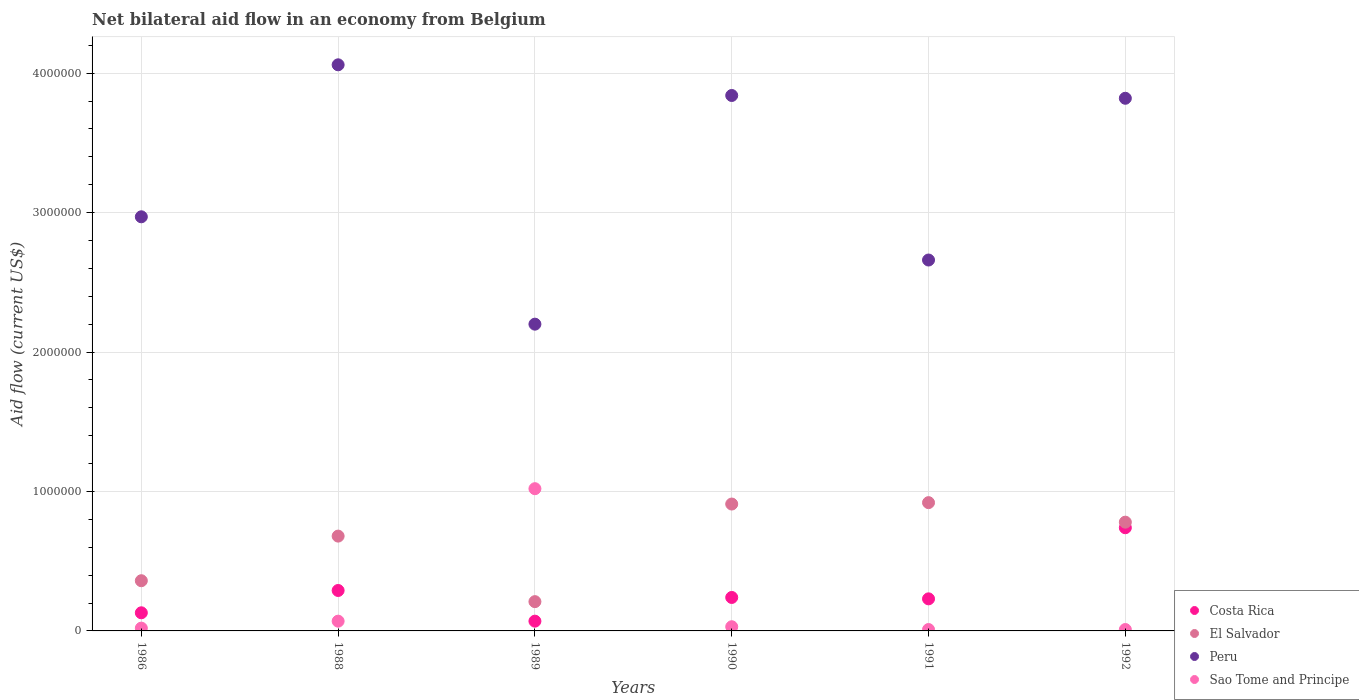Is the number of dotlines equal to the number of legend labels?
Ensure brevity in your answer.  Yes. What is the net bilateral aid flow in Costa Rica in 1986?
Your answer should be compact. 1.30e+05. Across all years, what is the maximum net bilateral aid flow in Costa Rica?
Make the answer very short. 7.40e+05. What is the total net bilateral aid flow in Peru in the graph?
Offer a very short reply. 1.96e+07. What is the difference between the net bilateral aid flow in Costa Rica in 1989 and that in 1992?
Make the answer very short. -6.70e+05. What is the difference between the net bilateral aid flow in Peru in 1989 and the net bilateral aid flow in El Salvador in 1990?
Make the answer very short. 1.29e+06. What is the average net bilateral aid flow in Peru per year?
Offer a terse response. 3.26e+06. In the year 1988, what is the difference between the net bilateral aid flow in Sao Tome and Principe and net bilateral aid flow in Costa Rica?
Ensure brevity in your answer.  -2.20e+05. What is the ratio of the net bilateral aid flow in Costa Rica in 1989 to that in 1990?
Your response must be concise. 0.29. Is the net bilateral aid flow in El Salvador in 1988 less than that in 1991?
Provide a short and direct response. Yes. Is the difference between the net bilateral aid flow in Sao Tome and Principe in 1988 and 1990 greater than the difference between the net bilateral aid flow in Costa Rica in 1988 and 1990?
Your answer should be very brief. No. What is the difference between the highest and the lowest net bilateral aid flow in Sao Tome and Principe?
Provide a short and direct response. 1.01e+06. In how many years, is the net bilateral aid flow in Costa Rica greater than the average net bilateral aid flow in Costa Rica taken over all years?
Your response must be concise. 2. Is the sum of the net bilateral aid flow in Costa Rica in 1990 and 1991 greater than the maximum net bilateral aid flow in El Salvador across all years?
Your answer should be compact. No. Is it the case that in every year, the sum of the net bilateral aid flow in Peru and net bilateral aid flow in Sao Tome and Principe  is greater than the sum of net bilateral aid flow in Costa Rica and net bilateral aid flow in El Salvador?
Offer a very short reply. Yes. Is it the case that in every year, the sum of the net bilateral aid flow in El Salvador and net bilateral aid flow in Peru  is greater than the net bilateral aid flow in Costa Rica?
Offer a terse response. Yes. Does the net bilateral aid flow in Costa Rica monotonically increase over the years?
Offer a terse response. No. Is the net bilateral aid flow in El Salvador strictly less than the net bilateral aid flow in Costa Rica over the years?
Your answer should be compact. No. How many dotlines are there?
Your answer should be very brief. 4. What is the difference between two consecutive major ticks on the Y-axis?
Provide a short and direct response. 1.00e+06. Does the graph contain grids?
Your answer should be very brief. Yes. How many legend labels are there?
Your answer should be compact. 4. How are the legend labels stacked?
Your answer should be very brief. Vertical. What is the title of the graph?
Provide a succinct answer. Net bilateral aid flow in an economy from Belgium. Does "St. Lucia" appear as one of the legend labels in the graph?
Ensure brevity in your answer.  No. What is the label or title of the X-axis?
Offer a terse response. Years. What is the label or title of the Y-axis?
Ensure brevity in your answer.  Aid flow (current US$). What is the Aid flow (current US$) of Peru in 1986?
Make the answer very short. 2.97e+06. What is the Aid flow (current US$) of El Salvador in 1988?
Your answer should be compact. 6.80e+05. What is the Aid flow (current US$) in Peru in 1988?
Make the answer very short. 4.06e+06. What is the Aid flow (current US$) of Sao Tome and Principe in 1988?
Offer a very short reply. 7.00e+04. What is the Aid flow (current US$) in Costa Rica in 1989?
Ensure brevity in your answer.  7.00e+04. What is the Aid flow (current US$) of El Salvador in 1989?
Offer a very short reply. 2.10e+05. What is the Aid flow (current US$) of Peru in 1989?
Your answer should be compact. 2.20e+06. What is the Aid flow (current US$) of Sao Tome and Principe in 1989?
Ensure brevity in your answer.  1.02e+06. What is the Aid flow (current US$) in El Salvador in 1990?
Give a very brief answer. 9.10e+05. What is the Aid flow (current US$) in Peru in 1990?
Make the answer very short. 3.84e+06. What is the Aid flow (current US$) of Costa Rica in 1991?
Make the answer very short. 2.30e+05. What is the Aid flow (current US$) in El Salvador in 1991?
Your response must be concise. 9.20e+05. What is the Aid flow (current US$) of Peru in 1991?
Offer a very short reply. 2.66e+06. What is the Aid flow (current US$) of Sao Tome and Principe in 1991?
Your answer should be compact. 10000. What is the Aid flow (current US$) in Costa Rica in 1992?
Provide a short and direct response. 7.40e+05. What is the Aid flow (current US$) in El Salvador in 1992?
Ensure brevity in your answer.  7.80e+05. What is the Aid flow (current US$) of Peru in 1992?
Keep it short and to the point. 3.82e+06. What is the Aid flow (current US$) in Sao Tome and Principe in 1992?
Offer a very short reply. 10000. Across all years, what is the maximum Aid flow (current US$) in Costa Rica?
Your response must be concise. 7.40e+05. Across all years, what is the maximum Aid flow (current US$) of El Salvador?
Make the answer very short. 9.20e+05. Across all years, what is the maximum Aid flow (current US$) in Peru?
Your answer should be very brief. 4.06e+06. Across all years, what is the maximum Aid flow (current US$) in Sao Tome and Principe?
Offer a very short reply. 1.02e+06. Across all years, what is the minimum Aid flow (current US$) in Costa Rica?
Your response must be concise. 7.00e+04. Across all years, what is the minimum Aid flow (current US$) of El Salvador?
Keep it short and to the point. 2.10e+05. Across all years, what is the minimum Aid flow (current US$) of Peru?
Offer a terse response. 2.20e+06. What is the total Aid flow (current US$) in Costa Rica in the graph?
Keep it short and to the point. 1.70e+06. What is the total Aid flow (current US$) in El Salvador in the graph?
Offer a very short reply. 3.86e+06. What is the total Aid flow (current US$) in Peru in the graph?
Ensure brevity in your answer.  1.96e+07. What is the total Aid flow (current US$) in Sao Tome and Principe in the graph?
Ensure brevity in your answer.  1.16e+06. What is the difference between the Aid flow (current US$) of Costa Rica in 1986 and that in 1988?
Provide a short and direct response. -1.60e+05. What is the difference between the Aid flow (current US$) in El Salvador in 1986 and that in 1988?
Your answer should be compact. -3.20e+05. What is the difference between the Aid flow (current US$) in Peru in 1986 and that in 1988?
Your response must be concise. -1.09e+06. What is the difference between the Aid flow (current US$) in El Salvador in 1986 and that in 1989?
Keep it short and to the point. 1.50e+05. What is the difference between the Aid flow (current US$) of Peru in 1986 and that in 1989?
Your answer should be very brief. 7.70e+05. What is the difference between the Aid flow (current US$) in Costa Rica in 1986 and that in 1990?
Make the answer very short. -1.10e+05. What is the difference between the Aid flow (current US$) of El Salvador in 1986 and that in 1990?
Offer a very short reply. -5.50e+05. What is the difference between the Aid flow (current US$) in Peru in 1986 and that in 1990?
Make the answer very short. -8.70e+05. What is the difference between the Aid flow (current US$) of Costa Rica in 1986 and that in 1991?
Make the answer very short. -1.00e+05. What is the difference between the Aid flow (current US$) in El Salvador in 1986 and that in 1991?
Provide a succinct answer. -5.60e+05. What is the difference between the Aid flow (current US$) of Peru in 1986 and that in 1991?
Your response must be concise. 3.10e+05. What is the difference between the Aid flow (current US$) of Costa Rica in 1986 and that in 1992?
Ensure brevity in your answer.  -6.10e+05. What is the difference between the Aid flow (current US$) in El Salvador in 1986 and that in 1992?
Your response must be concise. -4.20e+05. What is the difference between the Aid flow (current US$) in Peru in 1986 and that in 1992?
Keep it short and to the point. -8.50e+05. What is the difference between the Aid flow (current US$) of Sao Tome and Principe in 1986 and that in 1992?
Your answer should be very brief. 10000. What is the difference between the Aid flow (current US$) in Peru in 1988 and that in 1989?
Offer a very short reply. 1.86e+06. What is the difference between the Aid flow (current US$) in Sao Tome and Principe in 1988 and that in 1989?
Offer a very short reply. -9.50e+05. What is the difference between the Aid flow (current US$) in Peru in 1988 and that in 1990?
Your answer should be very brief. 2.20e+05. What is the difference between the Aid flow (current US$) in Sao Tome and Principe in 1988 and that in 1990?
Ensure brevity in your answer.  4.00e+04. What is the difference between the Aid flow (current US$) of El Salvador in 1988 and that in 1991?
Make the answer very short. -2.40e+05. What is the difference between the Aid flow (current US$) of Peru in 1988 and that in 1991?
Offer a very short reply. 1.40e+06. What is the difference between the Aid flow (current US$) in Sao Tome and Principe in 1988 and that in 1991?
Ensure brevity in your answer.  6.00e+04. What is the difference between the Aid flow (current US$) of Costa Rica in 1988 and that in 1992?
Ensure brevity in your answer.  -4.50e+05. What is the difference between the Aid flow (current US$) of El Salvador in 1988 and that in 1992?
Ensure brevity in your answer.  -1.00e+05. What is the difference between the Aid flow (current US$) in Peru in 1988 and that in 1992?
Provide a short and direct response. 2.40e+05. What is the difference between the Aid flow (current US$) of Costa Rica in 1989 and that in 1990?
Keep it short and to the point. -1.70e+05. What is the difference between the Aid flow (current US$) of El Salvador in 1989 and that in 1990?
Your answer should be very brief. -7.00e+05. What is the difference between the Aid flow (current US$) of Peru in 1989 and that in 1990?
Ensure brevity in your answer.  -1.64e+06. What is the difference between the Aid flow (current US$) in Sao Tome and Principe in 1989 and that in 1990?
Your answer should be compact. 9.90e+05. What is the difference between the Aid flow (current US$) in Costa Rica in 1989 and that in 1991?
Your answer should be compact. -1.60e+05. What is the difference between the Aid flow (current US$) of El Salvador in 1989 and that in 1991?
Provide a succinct answer. -7.10e+05. What is the difference between the Aid flow (current US$) of Peru in 1989 and that in 1991?
Ensure brevity in your answer.  -4.60e+05. What is the difference between the Aid flow (current US$) in Sao Tome and Principe in 1989 and that in 1991?
Offer a terse response. 1.01e+06. What is the difference between the Aid flow (current US$) in Costa Rica in 1989 and that in 1992?
Ensure brevity in your answer.  -6.70e+05. What is the difference between the Aid flow (current US$) of El Salvador in 1989 and that in 1992?
Make the answer very short. -5.70e+05. What is the difference between the Aid flow (current US$) in Peru in 1989 and that in 1992?
Make the answer very short. -1.62e+06. What is the difference between the Aid flow (current US$) in Sao Tome and Principe in 1989 and that in 1992?
Your response must be concise. 1.01e+06. What is the difference between the Aid flow (current US$) in El Salvador in 1990 and that in 1991?
Ensure brevity in your answer.  -10000. What is the difference between the Aid flow (current US$) of Peru in 1990 and that in 1991?
Offer a very short reply. 1.18e+06. What is the difference between the Aid flow (current US$) in Costa Rica in 1990 and that in 1992?
Keep it short and to the point. -5.00e+05. What is the difference between the Aid flow (current US$) in El Salvador in 1990 and that in 1992?
Your response must be concise. 1.30e+05. What is the difference between the Aid flow (current US$) in Sao Tome and Principe in 1990 and that in 1992?
Your answer should be compact. 2.00e+04. What is the difference between the Aid flow (current US$) in Costa Rica in 1991 and that in 1992?
Your response must be concise. -5.10e+05. What is the difference between the Aid flow (current US$) of El Salvador in 1991 and that in 1992?
Your answer should be compact. 1.40e+05. What is the difference between the Aid flow (current US$) of Peru in 1991 and that in 1992?
Your response must be concise. -1.16e+06. What is the difference between the Aid flow (current US$) in Costa Rica in 1986 and the Aid flow (current US$) in El Salvador in 1988?
Offer a terse response. -5.50e+05. What is the difference between the Aid flow (current US$) of Costa Rica in 1986 and the Aid flow (current US$) of Peru in 1988?
Offer a very short reply. -3.93e+06. What is the difference between the Aid flow (current US$) of Costa Rica in 1986 and the Aid flow (current US$) of Sao Tome and Principe in 1988?
Provide a succinct answer. 6.00e+04. What is the difference between the Aid flow (current US$) of El Salvador in 1986 and the Aid flow (current US$) of Peru in 1988?
Give a very brief answer. -3.70e+06. What is the difference between the Aid flow (current US$) in El Salvador in 1986 and the Aid flow (current US$) in Sao Tome and Principe in 1988?
Provide a succinct answer. 2.90e+05. What is the difference between the Aid flow (current US$) in Peru in 1986 and the Aid flow (current US$) in Sao Tome and Principe in 1988?
Provide a short and direct response. 2.90e+06. What is the difference between the Aid flow (current US$) in Costa Rica in 1986 and the Aid flow (current US$) in Peru in 1989?
Offer a terse response. -2.07e+06. What is the difference between the Aid flow (current US$) in Costa Rica in 1986 and the Aid flow (current US$) in Sao Tome and Principe in 1989?
Keep it short and to the point. -8.90e+05. What is the difference between the Aid flow (current US$) of El Salvador in 1986 and the Aid flow (current US$) of Peru in 1989?
Ensure brevity in your answer.  -1.84e+06. What is the difference between the Aid flow (current US$) in El Salvador in 1986 and the Aid flow (current US$) in Sao Tome and Principe in 1989?
Ensure brevity in your answer.  -6.60e+05. What is the difference between the Aid flow (current US$) in Peru in 1986 and the Aid flow (current US$) in Sao Tome and Principe in 1989?
Provide a short and direct response. 1.95e+06. What is the difference between the Aid flow (current US$) in Costa Rica in 1986 and the Aid flow (current US$) in El Salvador in 1990?
Make the answer very short. -7.80e+05. What is the difference between the Aid flow (current US$) in Costa Rica in 1986 and the Aid flow (current US$) in Peru in 1990?
Provide a short and direct response. -3.71e+06. What is the difference between the Aid flow (current US$) in Costa Rica in 1986 and the Aid flow (current US$) in Sao Tome and Principe in 1990?
Keep it short and to the point. 1.00e+05. What is the difference between the Aid flow (current US$) in El Salvador in 1986 and the Aid flow (current US$) in Peru in 1990?
Give a very brief answer. -3.48e+06. What is the difference between the Aid flow (current US$) in Peru in 1986 and the Aid flow (current US$) in Sao Tome and Principe in 1990?
Keep it short and to the point. 2.94e+06. What is the difference between the Aid flow (current US$) of Costa Rica in 1986 and the Aid flow (current US$) of El Salvador in 1991?
Offer a terse response. -7.90e+05. What is the difference between the Aid flow (current US$) of Costa Rica in 1986 and the Aid flow (current US$) of Peru in 1991?
Make the answer very short. -2.53e+06. What is the difference between the Aid flow (current US$) in El Salvador in 1986 and the Aid flow (current US$) in Peru in 1991?
Keep it short and to the point. -2.30e+06. What is the difference between the Aid flow (current US$) in Peru in 1986 and the Aid flow (current US$) in Sao Tome and Principe in 1991?
Ensure brevity in your answer.  2.96e+06. What is the difference between the Aid flow (current US$) in Costa Rica in 1986 and the Aid flow (current US$) in El Salvador in 1992?
Provide a succinct answer. -6.50e+05. What is the difference between the Aid flow (current US$) of Costa Rica in 1986 and the Aid flow (current US$) of Peru in 1992?
Make the answer very short. -3.69e+06. What is the difference between the Aid flow (current US$) in Costa Rica in 1986 and the Aid flow (current US$) in Sao Tome and Principe in 1992?
Keep it short and to the point. 1.20e+05. What is the difference between the Aid flow (current US$) in El Salvador in 1986 and the Aid flow (current US$) in Peru in 1992?
Offer a terse response. -3.46e+06. What is the difference between the Aid flow (current US$) of Peru in 1986 and the Aid flow (current US$) of Sao Tome and Principe in 1992?
Provide a succinct answer. 2.96e+06. What is the difference between the Aid flow (current US$) of Costa Rica in 1988 and the Aid flow (current US$) of Peru in 1989?
Your response must be concise. -1.91e+06. What is the difference between the Aid flow (current US$) of Costa Rica in 1988 and the Aid flow (current US$) of Sao Tome and Principe in 1989?
Give a very brief answer. -7.30e+05. What is the difference between the Aid flow (current US$) in El Salvador in 1988 and the Aid flow (current US$) in Peru in 1989?
Ensure brevity in your answer.  -1.52e+06. What is the difference between the Aid flow (current US$) in El Salvador in 1988 and the Aid flow (current US$) in Sao Tome and Principe in 1989?
Your answer should be very brief. -3.40e+05. What is the difference between the Aid flow (current US$) in Peru in 1988 and the Aid flow (current US$) in Sao Tome and Principe in 1989?
Keep it short and to the point. 3.04e+06. What is the difference between the Aid flow (current US$) of Costa Rica in 1988 and the Aid flow (current US$) of El Salvador in 1990?
Make the answer very short. -6.20e+05. What is the difference between the Aid flow (current US$) of Costa Rica in 1988 and the Aid flow (current US$) of Peru in 1990?
Your answer should be compact. -3.55e+06. What is the difference between the Aid flow (current US$) in Costa Rica in 1988 and the Aid flow (current US$) in Sao Tome and Principe in 1990?
Your answer should be very brief. 2.60e+05. What is the difference between the Aid flow (current US$) of El Salvador in 1988 and the Aid flow (current US$) of Peru in 1990?
Your answer should be compact. -3.16e+06. What is the difference between the Aid flow (current US$) of El Salvador in 1988 and the Aid flow (current US$) of Sao Tome and Principe in 1990?
Your answer should be very brief. 6.50e+05. What is the difference between the Aid flow (current US$) in Peru in 1988 and the Aid flow (current US$) in Sao Tome and Principe in 1990?
Give a very brief answer. 4.03e+06. What is the difference between the Aid flow (current US$) in Costa Rica in 1988 and the Aid flow (current US$) in El Salvador in 1991?
Ensure brevity in your answer.  -6.30e+05. What is the difference between the Aid flow (current US$) of Costa Rica in 1988 and the Aid flow (current US$) of Peru in 1991?
Ensure brevity in your answer.  -2.37e+06. What is the difference between the Aid flow (current US$) of El Salvador in 1988 and the Aid flow (current US$) of Peru in 1991?
Make the answer very short. -1.98e+06. What is the difference between the Aid flow (current US$) of El Salvador in 1988 and the Aid flow (current US$) of Sao Tome and Principe in 1991?
Your response must be concise. 6.70e+05. What is the difference between the Aid flow (current US$) of Peru in 1988 and the Aid flow (current US$) of Sao Tome and Principe in 1991?
Your answer should be very brief. 4.05e+06. What is the difference between the Aid flow (current US$) in Costa Rica in 1988 and the Aid flow (current US$) in El Salvador in 1992?
Ensure brevity in your answer.  -4.90e+05. What is the difference between the Aid flow (current US$) of Costa Rica in 1988 and the Aid flow (current US$) of Peru in 1992?
Ensure brevity in your answer.  -3.53e+06. What is the difference between the Aid flow (current US$) in Costa Rica in 1988 and the Aid flow (current US$) in Sao Tome and Principe in 1992?
Offer a very short reply. 2.80e+05. What is the difference between the Aid flow (current US$) in El Salvador in 1988 and the Aid flow (current US$) in Peru in 1992?
Make the answer very short. -3.14e+06. What is the difference between the Aid flow (current US$) in El Salvador in 1988 and the Aid flow (current US$) in Sao Tome and Principe in 1992?
Give a very brief answer. 6.70e+05. What is the difference between the Aid flow (current US$) in Peru in 1988 and the Aid flow (current US$) in Sao Tome and Principe in 1992?
Ensure brevity in your answer.  4.05e+06. What is the difference between the Aid flow (current US$) in Costa Rica in 1989 and the Aid flow (current US$) in El Salvador in 1990?
Your answer should be compact. -8.40e+05. What is the difference between the Aid flow (current US$) in Costa Rica in 1989 and the Aid flow (current US$) in Peru in 1990?
Make the answer very short. -3.77e+06. What is the difference between the Aid flow (current US$) in El Salvador in 1989 and the Aid flow (current US$) in Peru in 1990?
Make the answer very short. -3.63e+06. What is the difference between the Aid flow (current US$) in El Salvador in 1989 and the Aid flow (current US$) in Sao Tome and Principe in 1990?
Make the answer very short. 1.80e+05. What is the difference between the Aid flow (current US$) of Peru in 1989 and the Aid flow (current US$) of Sao Tome and Principe in 1990?
Your answer should be very brief. 2.17e+06. What is the difference between the Aid flow (current US$) in Costa Rica in 1989 and the Aid flow (current US$) in El Salvador in 1991?
Offer a terse response. -8.50e+05. What is the difference between the Aid flow (current US$) of Costa Rica in 1989 and the Aid flow (current US$) of Peru in 1991?
Provide a short and direct response. -2.59e+06. What is the difference between the Aid flow (current US$) in El Salvador in 1989 and the Aid flow (current US$) in Peru in 1991?
Your answer should be very brief. -2.45e+06. What is the difference between the Aid flow (current US$) of Peru in 1989 and the Aid flow (current US$) of Sao Tome and Principe in 1991?
Keep it short and to the point. 2.19e+06. What is the difference between the Aid flow (current US$) of Costa Rica in 1989 and the Aid flow (current US$) of El Salvador in 1992?
Provide a short and direct response. -7.10e+05. What is the difference between the Aid flow (current US$) in Costa Rica in 1989 and the Aid flow (current US$) in Peru in 1992?
Offer a very short reply. -3.75e+06. What is the difference between the Aid flow (current US$) of El Salvador in 1989 and the Aid flow (current US$) of Peru in 1992?
Provide a succinct answer. -3.61e+06. What is the difference between the Aid flow (current US$) in Peru in 1989 and the Aid flow (current US$) in Sao Tome and Principe in 1992?
Make the answer very short. 2.19e+06. What is the difference between the Aid flow (current US$) of Costa Rica in 1990 and the Aid flow (current US$) of El Salvador in 1991?
Keep it short and to the point. -6.80e+05. What is the difference between the Aid flow (current US$) in Costa Rica in 1990 and the Aid flow (current US$) in Peru in 1991?
Provide a succinct answer. -2.42e+06. What is the difference between the Aid flow (current US$) in Costa Rica in 1990 and the Aid flow (current US$) in Sao Tome and Principe in 1991?
Provide a succinct answer. 2.30e+05. What is the difference between the Aid flow (current US$) in El Salvador in 1990 and the Aid flow (current US$) in Peru in 1991?
Offer a very short reply. -1.75e+06. What is the difference between the Aid flow (current US$) in Peru in 1990 and the Aid flow (current US$) in Sao Tome and Principe in 1991?
Ensure brevity in your answer.  3.83e+06. What is the difference between the Aid flow (current US$) in Costa Rica in 1990 and the Aid flow (current US$) in El Salvador in 1992?
Give a very brief answer. -5.40e+05. What is the difference between the Aid flow (current US$) in Costa Rica in 1990 and the Aid flow (current US$) in Peru in 1992?
Provide a short and direct response. -3.58e+06. What is the difference between the Aid flow (current US$) of Costa Rica in 1990 and the Aid flow (current US$) of Sao Tome and Principe in 1992?
Ensure brevity in your answer.  2.30e+05. What is the difference between the Aid flow (current US$) in El Salvador in 1990 and the Aid flow (current US$) in Peru in 1992?
Your answer should be compact. -2.91e+06. What is the difference between the Aid flow (current US$) in El Salvador in 1990 and the Aid flow (current US$) in Sao Tome and Principe in 1992?
Offer a terse response. 9.00e+05. What is the difference between the Aid flow (current US$) in Peru in 1990 and the Aid flow (current US$) in Sao Tome and Principe in 1992?
Offer a terse response. 3.83e+06. What is the difference between the Aid flow (current US$) in Costa Rica in 1991 and the Aid flow (current US$) in El Salvador in 1992?
Your answer should be compact. -5.50e+05. What is the difference between the Aid flow (current US$) of Costa Rica in 1991 and the Aid flow (current US$) of Peru in 1992?
Keep it short and to the point. -3.59e+06. What is the difference between the Aid flow (current US$) in Costa Rica in 1991 and the Aid flow (current US$) in Sao Tome and Principe in 1992?
Offer a very short reply. 2.20e+05. What is the difference between the Aid flow (current US$) of El Salvador in 1991 and the Aid flow (current US$) of Peru in 1992?
Your answer should be very brief. -2.90e+06. What is the difference between the Aid flow (current US$) in El Salvador in 1991 and the Aid flow (current US$) in Sao Tome and Principe in 1992?
Your answer should be very brief. 9.10e+05. What is the difference between the Aid flow (current US$) in Peru in 1991 and the Aid flow (current US$) in Sao Tome and Principe in 1992?
Provide a short and direct response. 2.65e+06. What is the average Aid flow (current US$) in Costa Rica per year?
Ensure brevity in your answer.  2.83e+05. What is the average Aid flow (current US$) in El Salvador per year?
Offer a very short reply. 6.43e+05. What is the average Aid flow (current US$) of Peru per year?
Ensure brevity in your answer.  3.26e+06. What is the average Aid flow (current US$) of Sao Tome and Principe per year?
Keep it short and to the point. 1.93e+05. In the year 1986, what is the difference between the Aid flow (current US$) in Costa Rica and Aid flow (current US$) in Peru?
Give a very brief answer. -2.84e+06. In the year 1986, what is the difference between the Aid flow (current US$) of El Salvador and Aid flow (current US$) of Peru?
Give a very brief answer. -2.61e+06. In the year 1986, what is the difference between the Aid flow (current US$) in Peru and Aid flow (current US$) in Sao Tome and Principe?
Make the answer very short. 2.95e+06. In the year 1988, what is the difference between the Aid flow (current US$) of Costa Rica and Aid flow (current US$) of El Salvador?
Your response must be concise. -3.90e+05. In the year 1988, what is the difference between the Aid flow (current US$) of Costa Rica and Aid flow (current US$) of Peru?
Provide a short and direct response. -3.77e+06. In the year 1988, what is the difference between the Aid flow (current US$) of Costa Rica and Aid flow (current US$) of Sao Tome and Principe?
Offer a terse response. 2.20e+05. In the year 1988, what is the difference between the Aid flow (current US$) in El Salvador and Aid flow (current US$) in Peru?
Give a very brief answer. -3.38e+06. In the year 1988, what is the difference between the Aid flow (current US$) of El Salvador and Aid flow (current US$) of Sao Tome and Principe?
Keep it short and to the point. 6.10e+05. In the year 1988, what is the difference between the Aid flow (current US$) in Peru and Aid flow (current US$) in Sao Tome and Principe?
Offer a terse response. 3.99e+06. In the year 1989, what is the difference between the Aid flow (current US$) of Costa Rica and Aid flow (current US$) of El Salvador?
Keep it short and to the point. -1.40e+05. In the year 1989, what is the difference between the Aid flow (current US$) of Costa Rica and Aid flow (current US$) of Peru?
Provide a short and direct response. -2.13e+06. In the year 1989, what is the difference between the Aid flow (current US$) in Costa Rica and Aid flow (current US$) in Sao Tome and Principe?
Provide a succinct answer. -9.50e+05. In the year 1989, what is the difference between the Aid flow (current US$) of El Salvador and Aid flow (current US$) of Peru?
Offer a very short reply. -1.99e+06. In the year 1989, what is the difference between the Aid flow (current US$) of El Salvador and Aid flow (current US$) of Sao Tome and Principe?
Keep it short and to the point. -8.10e+05. In the year 1989, what is the difference between the Aid flow (current US$) in Peru and Aid flow (current US$) in Sao Tome and Principe?
Offer a terse response. 1.18e+06. In the year 1990, what is the difference between the Aid flow (current US$) in Costa Rica and Aid flow (current US$) in El Salvador?
Ensure brevity in your answer.  -6.70e+05. In the year 1990, what is the difference between the Aid flow (current US$) in Costa Rica and Aid flow (current US$) in Peru?
Offer a terse response. -3.60e+06. In the year 1990, what is the difference between the Aid flow (current US$) of El Salvador and Aid flow (current US$) of Peru?
Give a very brief answer. -2.93e+06. In the year 1990, what is the difference between the Aid flow (current US$) of El Salvador and Aid flow (current US$) of Sao Tome and Principe?
Your response must be concise. 8.80e+05. In the year 1990, what is the difference between the Aid flow (current US$) of Peru and Aid flow (current US$) of Sao Tome and Principe?
Make the answer very short. 3.81e+06. In the year 1991, what is the difference between the Aid flow (current US$) of Costa Rica and Aid flow (current US$) of El Salvador?
Give a very brief answer. -6.90e+05. In the year 1991, what is the difference between the Aid flow (current US$) of Costa Rica and Aid flow (current US$) of Peru?
Your answer should be compact. -2.43e+06. In the year 1991, what is the difference between the Aid flow (current US$) in El Salvador and Aid flow (current US$) in Peru?
Provide a succinct answer. -1.74e+06. In the year 1991, what is the difference between the Aid flow (current US$) of El Salvador and Aid flow (current US$) of Sao Tome and Principe?
Ensure brevity in your answer.  9.10e+05. In the year 1991, what is the difference between the Aid flow (current US$) in Peru and Aid flow (current US$) in Sao Tome and Principe?
Provide a succinct answer. 2.65e+06. In the year 1992, what is the difference between the Aid flow (current US$) of Costa Rica and Aid flow (current US$) of Peru?
Make the answer very short. -3.08e+06. In the year 1992, what is the difference between the Aid flow (current US$) in Costa Rica and Aid flow (current US$) in Sao Tome and Principe?
Give a very brief answer. 7.30e+05. In the year 1992, what is the difference between the Aid flow (current US$) of El Salvador and Aid flow (current US$) of Peru?
Make the answer very short. -3.04e+06. In the year 1992, what is the difference between the Aid flow (current US$) in El Salvador and Aid flow (current US$) in Sao Tome and Principe?
Ensure brevity in your answer.  7.70e+05. In the year 1992, what is the difference between the Aid flow (current US$) in Peru and Aid flow (current US$) in Sao Tome and Principe?
Offer a terse response. 3.81e+06. What is the ratio of the Aid flow (current US$) of Costa Rica in 1986 to that in 1988?
Provide a short and direct response. 0.45. What is the ratio of the Aid flow (current US$) of El Salvador in 1986 to that in 1988?
Ensure brevity in your answer.  0.53. What is the ratio of the Aid flow (current US$) of Peru in 1986 to that in 1988?
Your answer should be very brief. 0.73. What is the ratio of the Aid flow (current US$) of Sao Tome and Principe in 1986 to that in 1988?
Provide a succinct answer. 0.29. What is the ratio of the Aid flow (current US$) of Costa Rica in 1986 to that in 1989?
Offer a terse response. 1.86. What is the ratio of the Aid flow (current US$) in El Salvador in 1986 to that in 1989?
Offer a terse response. 1.71. What is the ratio of the Aid flow (current US$) of Peru in 1986 to that in 1989?
Give a very brief answer. 1.35. What is the ratio of the Aid flow (current US$) of Sao Tome and Principe in 1986 to that in 1989?
Your answer should be very brief. 0.02. What is the ratio of the Aid flow (current US$) of Costa Rica in 1986 to that in 1990?
Make the answer very short. 0.54. What is the ratio of the Aid flow (current US$) in El Salvador in 1986 to that in 1990?
Give a very brief answer. 0.4. What is the ratio of the Aid flow (current US$) in Peru in 1986 to that in 1990?
Your response must be concise. 0.77. What is the ratio of the Aid flow (current US$) in Costa Rica in 1986 to that in 1991?
Give a very brief answer. 0.57. What is the ratio of the Aid flow (current US$) in El Salvador in 1986 to that in 1991?
Provide a short and direct response. 0.39. What is the ratio of the Aid flow (current US$) of Peru in 1986 to that in 1991?
Provide a succinct answer. 1.12. What is the ratio of the Aid flow (current US$) in Costa Rica in 1986 to that in 1992?
Make the answer very short. 0.18. What is the ratio of the Aid flow (current US$) of El Salvador in 1986 to that in 1992?
Offer a terse response. 0.46. What is the ratio of the Aid flow (current US$) in Peru in 1986 to that in 1992?
Provide a short and direct response. 0.78. What is the ratio of the Aid flow (current US$) in Costa Rica in 1988 to that in 1989?
Provide a succinct answer. 4.14. What is the ratio of the Aid flow (current US$) in El Salvador in 1988 to that in 1989?
Your answer should be very brief. 3.24. What is the ratio of the Aid flow (current US$) of Peru in 1988 to that in 1989?
Make the answer very short. 1.85. What is the ratio of the Aid flow (current US$) in Sao Tome and Principe in 1988 to that in 1989?
Offer a terse response. 0.07. What is the ratio of the Aid flow (current US$) of Costa Rica in 1988 to that in 1990?
Your response must be concise. 1.21. What is the ratio of the Aid flow (current US$) of El Salvador in 1988 to that in 1990?
Ensure brevity in your answer.  0.75. What is the ratio of the Aid flow (current US$) of Peru in 1988 to that in 1990?
Your answer should be compact. 1.06. What is the ratio of the Aid flow (current US$) in Sao Tome and Principe in 1988 to that in 1990?
Ensure brevity in your answer.  2.33. What is the ratio of the Aid flow (current US$) in Costa Rica in 1988 to that in 1991?
Make the answer very short. 1.26. What is the ratio of the Aid flow (current US$) in El Salvador in 1988 to that in 1991?
Offer a very short reply. 0.74. What is the ratio of the Aid flow (current US$) of Peru in 1988 to that in 1991?
Your answer should be very brief. 1.53. What is the ratio of the Aid flow (current US$) in Sao Tome and Principe in 1988 to that in 1991?
Give a very brief answer. 7. What is the ratio of the Aid flow (current US$) in Costa Rica in 1988 to that in 1992?
Make the answer very short. 0.39. What is the ratio of the Aid flow (current US$) in El Salvador in 1988 to that in 1992?
Ensure brevity in your answer.  0.87. What is the ratio of the Aid flow (current US$) of Peru in 1988 to that in 1992?
Your answer should be compact. 1.06. What is the ratio of the Aid flow (current US$) of Costa Rica in 1989 to that in 1990?
Provide a succinct answer. 0.29. What is the ratio of the Aid flow (current US$) in El Salvador in 1989 to that in 1990?
Your answer should be very brief. 0.23. What is the ratio of the Aid flow (current US$) of Peru in 1989 to that in 1990?
Provide a short and direct response. 0.57. What is the ratio of the Aid flow (current US$) of Costa Rica in 1989 to that in 1991?
Your answer should be compact. 0.3. What is the ratio of the Aid flow (current US$) in El Salvador in 1989 to that in 1991?
Ensure brevity in your answer.  0.23. What is the ratio of the Aid flow (current US$) in Peru in 1989 to that in 1991?
Make the answer very short. 0.83. What is the ratio of the Aid flow (current US$) of Sao Tome and Principe in 1989 to that in 1991?
Give a very brief answer. 102. What is the ratio of the Aid flow (current US$) in Costa Rica in 1989 to that in 1992?
Keep it short and to the point. 0.09. What is the ratio of the Aid flow (current US$) in El Salvador in 1989 to that in 1992?
Provide a short and direct response. 0.27. What is the ratio of the Aid flow (current US$) in Peru in 1989 to that in 1992?
Provide a short and direct response. 0.58. What is the ratio of the Aid flow (current US$) of Sao Tome and Principe in 1989 to that in 1992?
Your answer should be very brief. 102. What is the ratio of the Aid flow (current US$) of Costa Rica in 1990 to that in 1991?
Your response must be concise. 1.04. What is the ratio of the Aid flow (current US$) in El Salvador in 1990 to that in 1991?
Provide a short and direct response. 0.99. What is the ratio of the Aid flow (current US$) in Peru in 1990 to that in 1991?
Make the answer very short. 1.44. What is the ratio of the Aid flow (current US$) of Costa Rica in 1990 to that in 1992?
Provide a succinct answer. 0.32. What is the ratio of the Aid flow (current US$) in El Salvador in 1990 to that in 1992?
Ensure brevity in your answer.  1.17. What is the ratio of the Aid flow (current US$) of Peru in 1990 to that in 1992?
Offer a very short reply. 1.01. What is the ratio of the Aid flow (current US$) of Costa Rica in 1991 to that in 1992?
Offer a terse response. 0.31. What is the ratio of the Aid flow (current US$) of El Salvador in 1991 to that in 1992?
Your answer should be compact. 1.18. What is the ratio of the Aid flow (current US$) in Peru in 1991 to that in 1992?
Provide a succinct answer. 0.7. What is the ratio of the Aid flow (current US$) of Sao Tome and Principe in 1991 to that in 1992?
Offer a very short reply. 1. What is the difference between the highest and the second highest Aid flow (current US$) in El Salvador?
Provide a short and direct response. 10000. What is the difference between the highest and the second highest Aid flow (current US$) in Peru?
Your answer should be very brief. 2.20e+05. What is the difference between the highest and the second highest Aid flow (current US$) in Sao Tome and Principe?
Give a very brief answer. 9.50e+05. What is the difference between the highest and the lowest Aid flow (current US$) of Costa Rica?
Your answer should be compact. 6.70e+05. What is the difference between the highest and the lowest Aid flow (current US$) of El Salvador?
Ensure brevity in your answer.  7.10e+05. What is the difference between the highest and the lowest Aid flow (current US$) in Peru?
Ensure brevity in your answer.  1.86e+06. What is the difference between the highest and the lowest Aid flow (current US$) of Sao Tome and Principe?
Your response must be concise. 1.01e+06. 